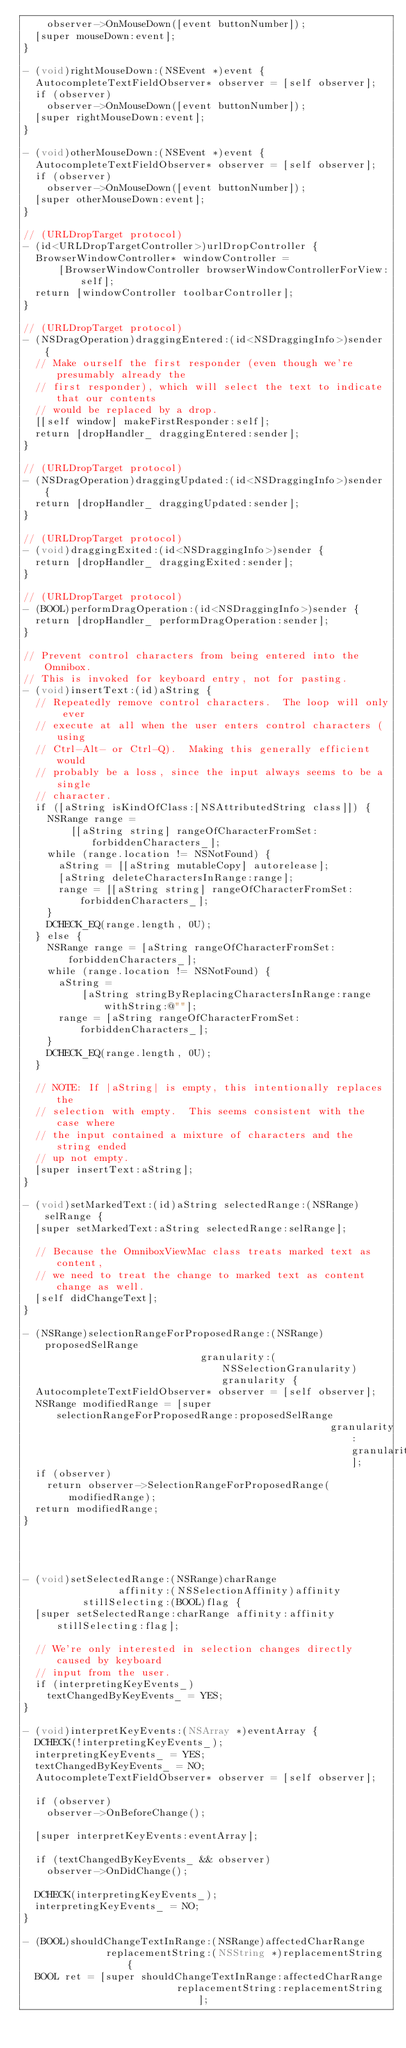<code> <loc_0><loc_0><loc_500><loc_500><_ObjectiveC_>    observer->OnMouseDown([event buttonNumber]);
  [super mouseDown:event];
}

- (void)rightMouseDown:(NSEvent *)event {
  AutocompleteTextFieldObserver* observer = [self observer];
  if (observer)
    observer->OnMouseDown([event buttonNumber]);
  [super rightMouseDown:event];
}

- (void)otherMouseDown:(NSEvent *)event {
  AutocompleteTextFieldObserver* observer = [self observer];
  if (observer)
    observer->OnMouseDown([event buttonNumber]);
  [super otherMouseDown:event];
}

// (URLDropTarget protocol)
- (id<URLDropTargetController>)urlDropController {
  BrowserWindowController* windowController =
      [BrowserWindowController browserWindowControllerForView:self];
  return [windowController toolbarController];
}

// (URLDropTarget protocol)
- (NSDragOperation)draggingEntered:(id<NSDraggingInfo>)sender {
  // Make ourself the first responder (even though we're presumably already the
  // first responder), which will select the text to indicate that our contents
  // would be replaced by a drop.
  [[self window] makeFirstResponder:self];
  return [dropHandler_ draggingEntered:sender];
}

// (URLDropTarget protocol)
- (NSDragOperation)draggingUpdated:(id<NSDraggingInfo>)sender {
  return [dropHandler_ draggingUpdated:sender];
}

// (URLDropTarget protocol)
- (void)draggingExited:(id<NSDraggingInfo>)sender {
  return [dropHandler_ draggingExited:sender];
}

// (URLDropTarget protocol)
- (BOOL)performDragOperation:(id<NSDraggingInfo>)sender {
  return [dropHandler_ performDragOperation:sender];
}

// Prevent control characters from being entered into the Omnibox.
// This is invoked for keyboard entry, not for pasting.
- (void)insertText:(id)aString {
  // Repeatedly remove control characters.  The loop will only ever
  // execute at all when the user enters control characters (using
  // Ctrl-Alt- or Ctrl-Q).  Making this generally efficient would
  // probably be a loss, since the input always seems to be a single
  // character.
  if ([aString isKindOfClass:[NSAttributedString class]]) {
    NSRange range =
        [[aString string] rangeOfCharacterFromSet:forbiddenCharacters_];
    while (range.location != NSNotFound) {
      aString = [[aString mutableCopy] autorelease];
      [aString deleteCharactersInRange:range];
      range = [[aString string] rangeOfCharacterFromSet:forbiddenCharacters_];
    }
    DCHECK_EQ(range.length, 0U);
  } else {
    NSRange range = [aString rangeOfCharacterFromSet:forbiddenCharacters_];
    while (range.location != NSNotFound) {
      aString =
          [aString stringByReplacingCharactersInRange:range withString:@""];
      range = [aString rangeOfCharacterFromSet:forbiddenCharacters_];
    }
    DCHECK_EQ(range.length, 0U);
  }

  // NOTE: If |aString| is empty, this intentionally replaces the
  // selection with empty.  This seems consistent with the case where
  // the input contained a mixture of characters and the string ended
  // up not empty.
  [super insertText:aString];
}

- (void)setMarkedText:(id)aString selectedRange:(NSRange)selRange {
  [super setMarkedText:aString selectedRange:selRange];

  // Because the OmniboxViewMac class treats marked text as content,
  // we need to treat the change to marked text as content change as well.
  [self didChangeText];
}

- (NSRange)selectionRangeForProposedRange:(NSRange)proposedSelRange
                              granularity:(NSSelectionGranularity)granularity {
  AutocompleteTextFieldObserver* observer = [self observer];
  NSRange modifiedRange = [super selectionRangeForProposedRange:proposedSelRange
                                                    granularity:granularity];
  if (observer)
    return observer->SelectionRangeForProposedRange(modifiedRange);
  return modifiedRange;
}




- (void)setSelectedRange:(NSRange)charRange
                affinity:(NSSelectionAffinity)affinity
          stillSelecting:(BOOL)flag {
  [super setSelectedRange:charRange affinity:affinity stillSelecting:flag];

  // We're only interested in selection changes directly caused by keyboard
  // input from the user.
  if (interpretingKeyEvents_)
    textChangedByKeyEvents_ = YES;
}

- (void)interpretKeyEvents:(NSArray *)eventArray {
  DCHECK(!interpretingKeyEvents_);
  interpretingKeyEvents_ = YES;
  textChangedByKeyEvents_ = NO;
  AutocompleteTextFieldObserver* observer = [self observer];

  if (observer)
    observer->OnBeforeChange();

  [super interpretKeyEvents:eventArray];

  if (textChangedByKeyEvents_ && observer)
    observer->OnDidChange();

  DCHECK(interpretingKeyEvents_);
  interpretingKeyEvents_ = NO;
}

- (BOOL)shouldChangeTextInRange:(NSRange)affectedCharRange
              replacementString:(NSString *)replacementString {
  BOOL ret = [super shouldChangeTextInRange:affectedCharRange
                          replacementString:replacementString];
</code> 